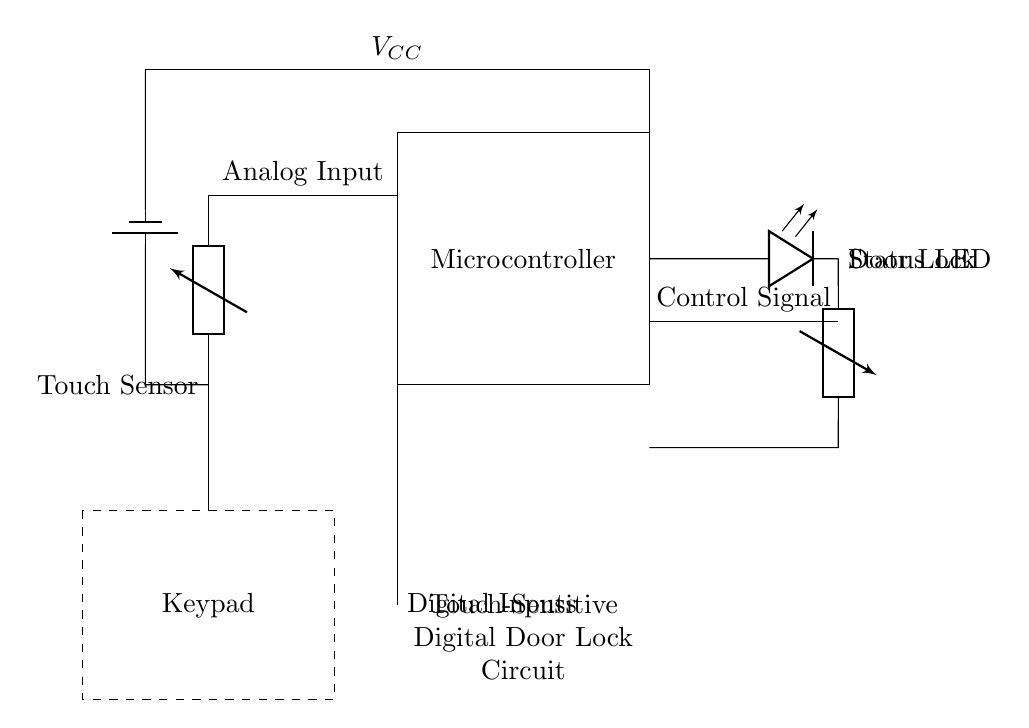What component is used for the door lock? The door lock mechanism is represented by a solenoid in the circuit diagram, which is typically used in electronic locks.
Answer: Solenoid What is the power supply voltage? The circuit indicates a power supply typically set to five volts, as shown above the microcontroller.
Answer: Five volts How does the touch sensor communicate with the microcontroller? The touch sensor connects to the microcontroller via an analog input, allowing it to process the information when touched.
Answer: Analog input What is the purpose of the status LED? The status LED provides visual feedback for the operation of the door lock, indicating whether the lock is secured or unlocked.
Answer: Visual feedback How many main components are shown in the circuit? The circuit diagram showcases four main components: the touch sensor, microcontroller, solenoid (door lock), and keypad.
Answer: Four What type of inputs does the keypad use? The keypad utilizes digital inputs to control the door locking mechanism. These inputs are essential for entering a passcode or security sequence.
Answer: Digital inputs What is the role of the microcontroller in this circuit? The microcontroller acts as the central processing unit that interprets the signals from the touch sensor and keypad to control the solenoid that locks or unlocks the door.
Answer: Central processing unit 